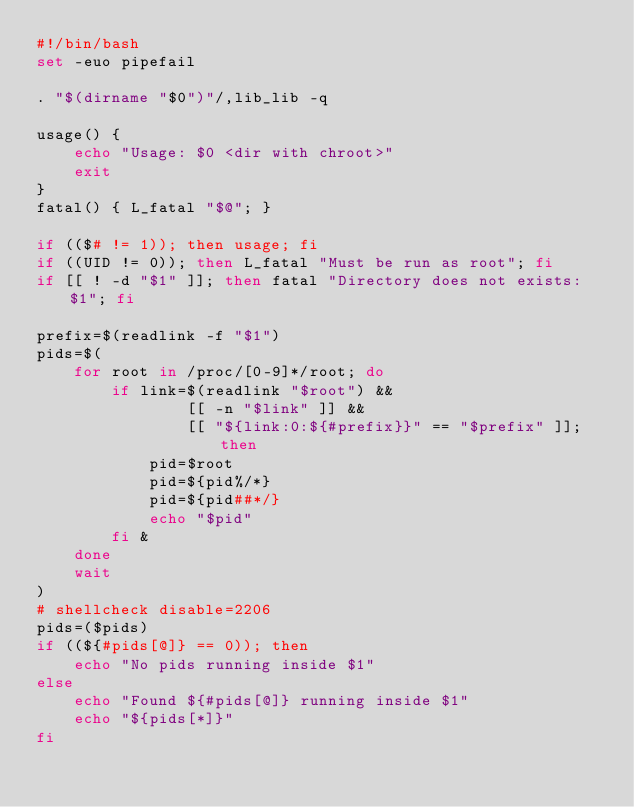<code> <loc_0><loc_0><loc_500><loc_500><_Bash_>#!/bin/bash
set -euo pipefail

. "$(dirname "$0")"/,lib_lib -q

usage() {
	echo "Usage: $0 <dir with chroot>"
	exit
}
fatal() { L_fatal "$@"; }

if (($# != 1)); then usage; fi
if ((UID != 0)); then L_fatal "Must be run as root"; fi
if [[ ! -d "$1" ]]; then fatal "Directory does not exists: $1"; fi

prefix=$(readlink -f "$1")
pids=$(
	for root in /proc/[0-9]*/root; do
		if link=$(readlink "$root") &&
				[[ -n "$link" ]] &&
				[[ "${link:0:${#prefix}}" == "$prefix" ]]; then
			pid=$root
			pid=${pid%/*}
			pid=${pid##*/}
			echo "$pid"
		fi &
	done
	wait
)
# shellcheck disable=2206
pids=($pids)
if ((${#pids[@]} == 0)); then
	echo "No pids running inside $1"
else
	echo "Found ${#pids[@]} running inside $1"
	echo "${pids[*]}"
fi

</code> 